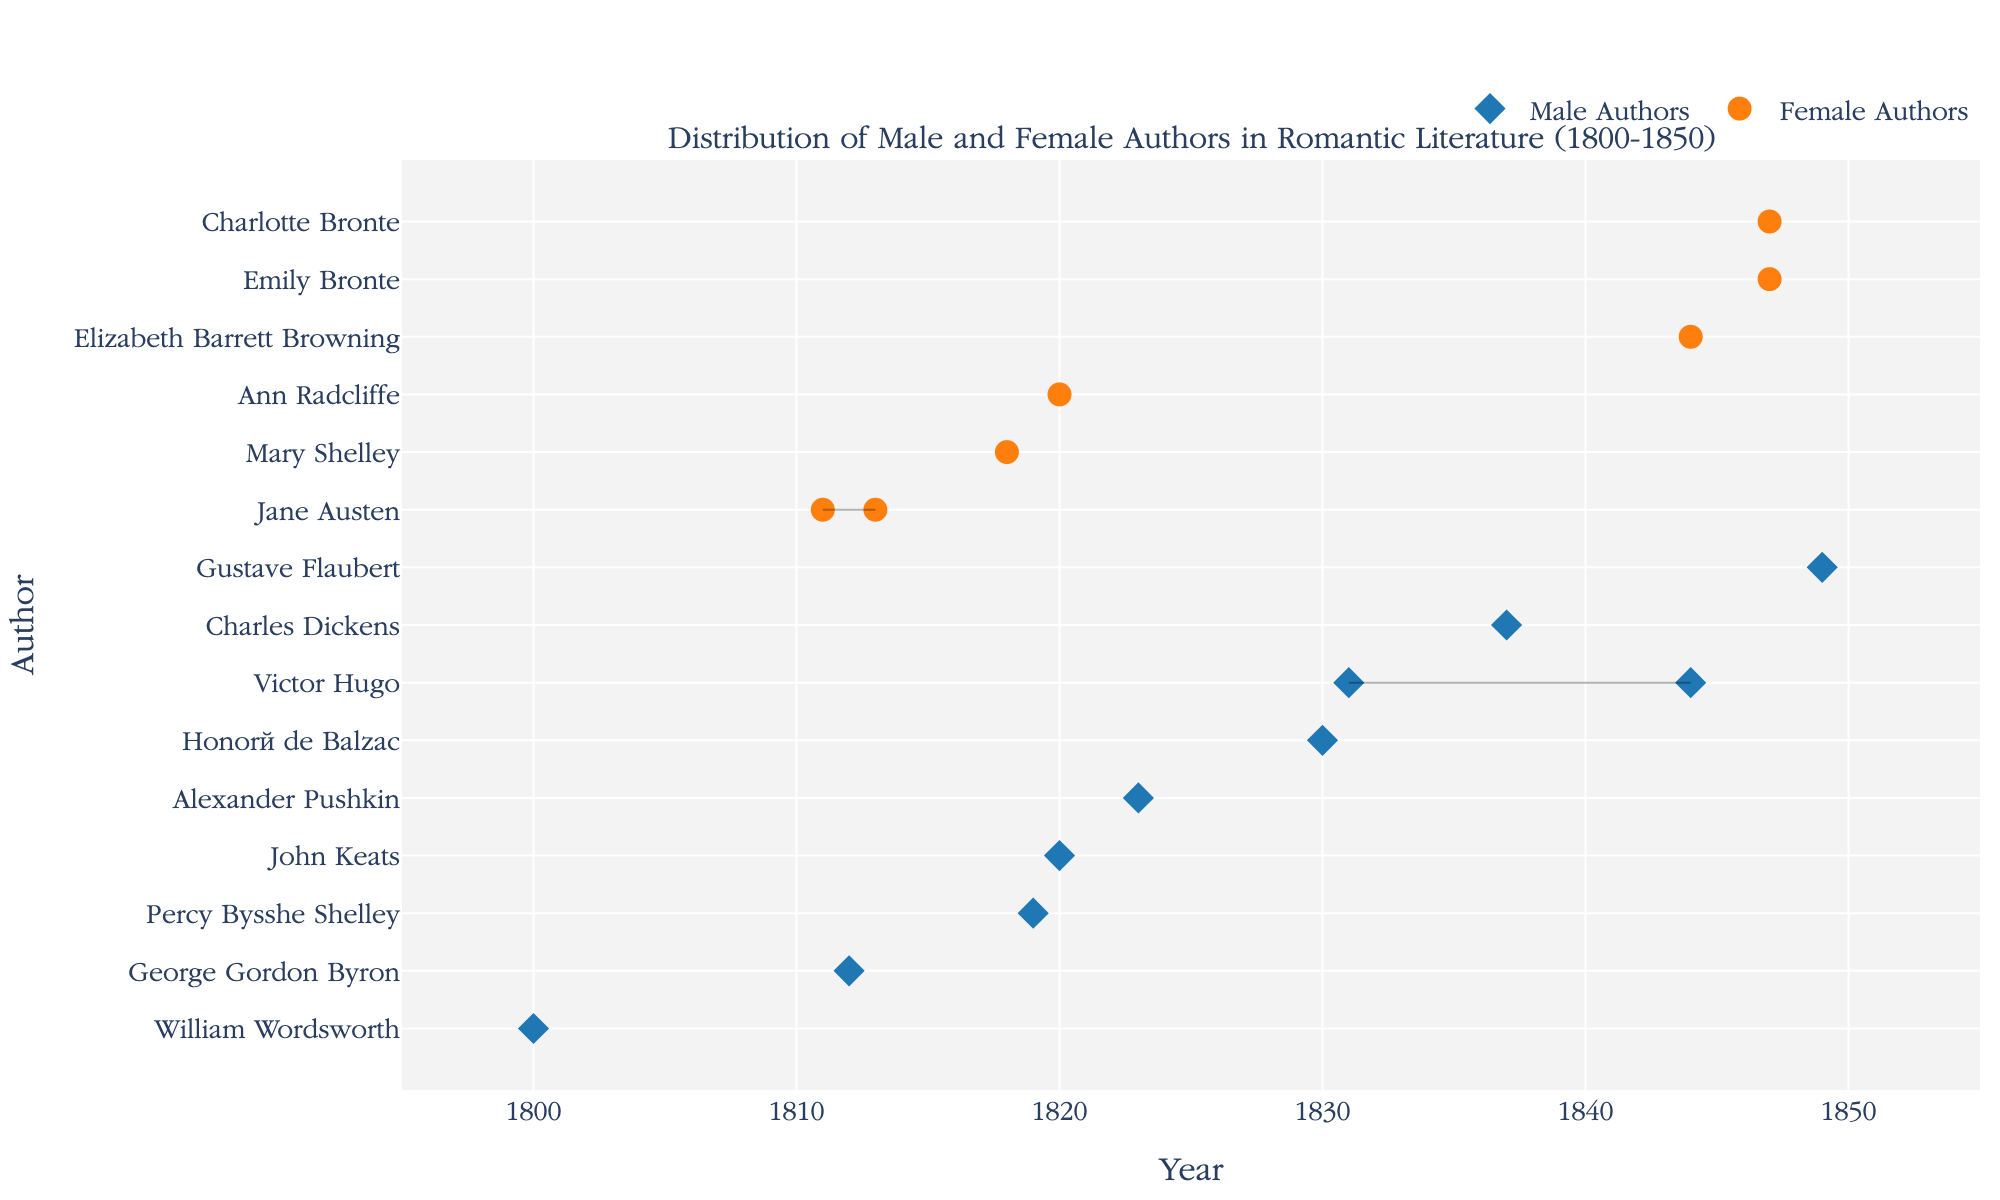What is the title of the figure? The title is typically located at the top of the graph and describes what the graph is about. In this case, the title is "Distribution of Male and Female Authors in Romantic Literature (1800-1850)".
Answer: Distribution of Male and Female Authors in Romantic Literature (1800-1850) How many female authors are represented in the figure? Female authors are represented by circular markers in the graph. Counting these markers, we get the total number of female authors.
Answer: 7 What colors represent male and female authors in the plot? Examining the legend, we see that male authors are represented by blue markers (diamonds) and female authors by orange markers (circles).
Answer: Blue for male, orange for female Which year does the plotted data start from and end at? The x-axis indicates the years. Observing the distribution of data points, the first year is 1800 and the last year is 1849.
Answer: 1800 to 1849 Identify the female author(s) who have more than one publication listed. By observing female authors (orange circles) on the y-axis, we notice that Jane Austen has multiple data points listed next to her name, indicating more than one publication.
Answer: Jane Austen Which male authors published works in 1830 or 1831? Looking at the x-axis for the years 1830 and 1831 and tracking corresponding y-axis labels, we find that Honoré de Balzac published in 1830 and Victor Hugo in 1831.
Answer: Honoré de Balzac and Victor Hugo Is there any author who has a publication in both 1844 and 1847? If so, who? By aligning the publication years 1844 and 1847 on the x-axis with points on the y-axis, we notice Victor Hugo in 1844 and both Charlotte and Emily Bronte in 1847. No single author appears in both years.
Answer: No How does the number of male authors compare to the number of female authors represented in the figure? Count all blue diamonds representing male authors and compare them to the count of orange circles. There are more male authors than female authors.
Answer: More male authors Which male author's publication was closest to 1800? Locate the earliest x-axis value among the blue diamonds and determine the corresponding y-axis label. William Wordsworth published in 1800.
Answer: William Wordsworth Which authors have publications connected by lines, and what does this signify? Lines connect multiple data points for an author, indicating that they have multiple publications in different years. Jane Austen, Victor Hugo, and the Bronte sisters have such connections.
Answer: Jane Austen, Victor Hugo, Charlotte Bronte, Emily Bronte 